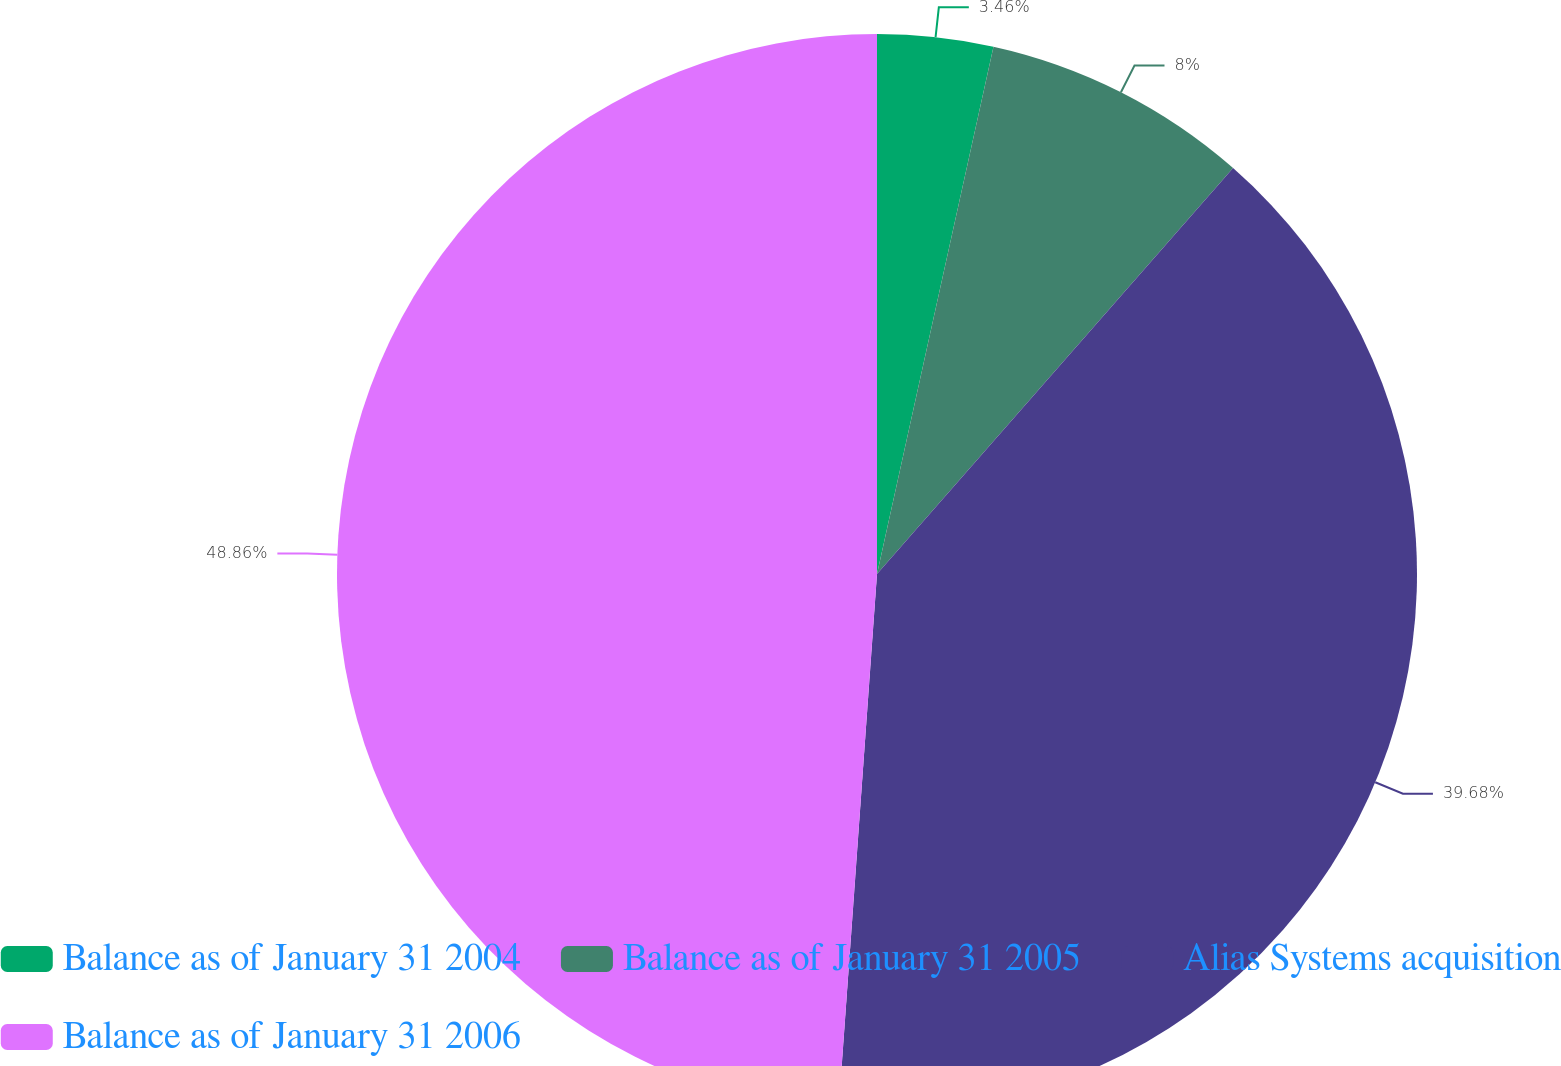<chart> <loc_0><loc_0><loc_500><loc_500><pie_chart><fcel>Balance as of January 31 2004<fcel>Balance as of January 31 2005<fcel>Alias Systems acquisition<fcel>Balance as of January 31 2006<nl><fcel>3.46%<fcel>8.0%<fcel>39.68%<fcel>48.86%<nl></chart> 